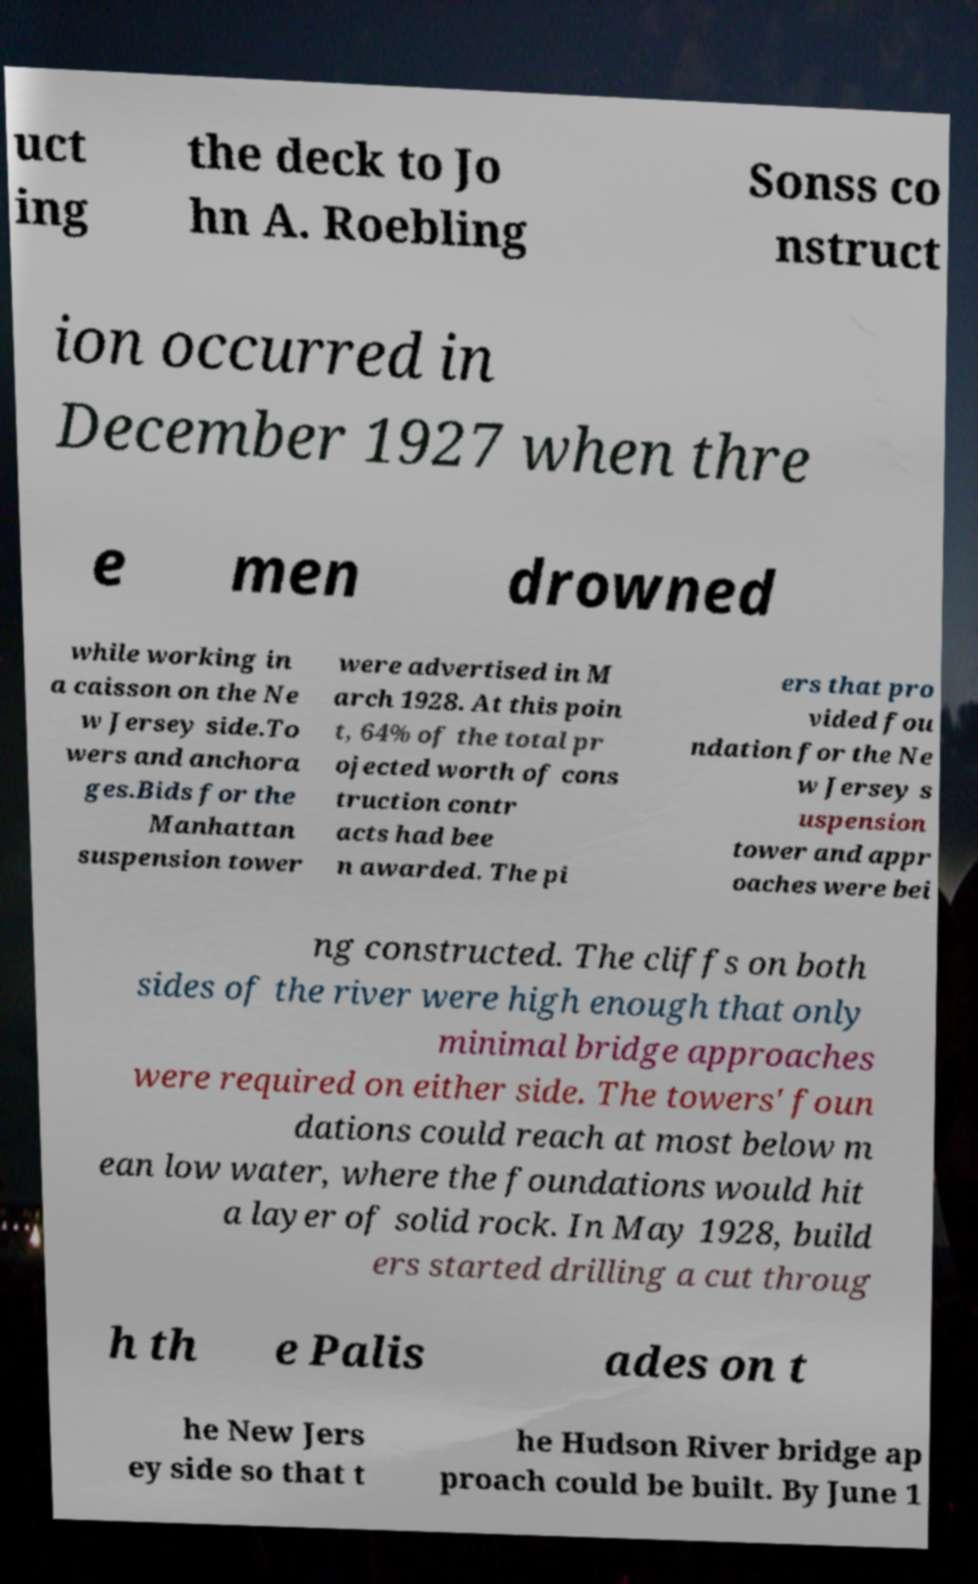Can you read and provide the text displayed in the image?This photo seems to have some interesting text. Can you extract and type it out for me? uct ing the deck to Jo hn A. Roebling Sonss co nstruct ion occurred in December 1927 when thre e men drowned while working in a caisson on the Ne w Jersey side.To wers and anchora ges.Bids for the Manhattan suspension tower were advertised in M arch 1928. At this poin t, 64% of the total pr ojected worth of cons truction contr acts had bee n awarded. The pi ers that pro vided fou ndation for the Ne w Jersey s uspension tower and appr oaches were bei ng constructed. The cliffs on both sides of the river were high enough that only minimal bridge approaches were required on either side. The towers' foun dations could reach at most below m ean low water, where the foundations would hit a layer of solid rock. In May 1928, build ers started drilling a cut throug h th e Palis ades on t he New Jers ey side so that t he Hudson River bridge ap proach could be built. By June 1 